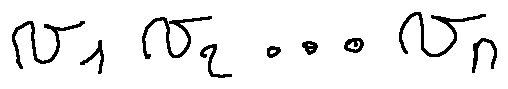Convert formula to latex. <formula><loc_0><loc_0><loc_500><loc_500>v _ { 1 } v _ { 2 } \dots v _ { n }</formula> 